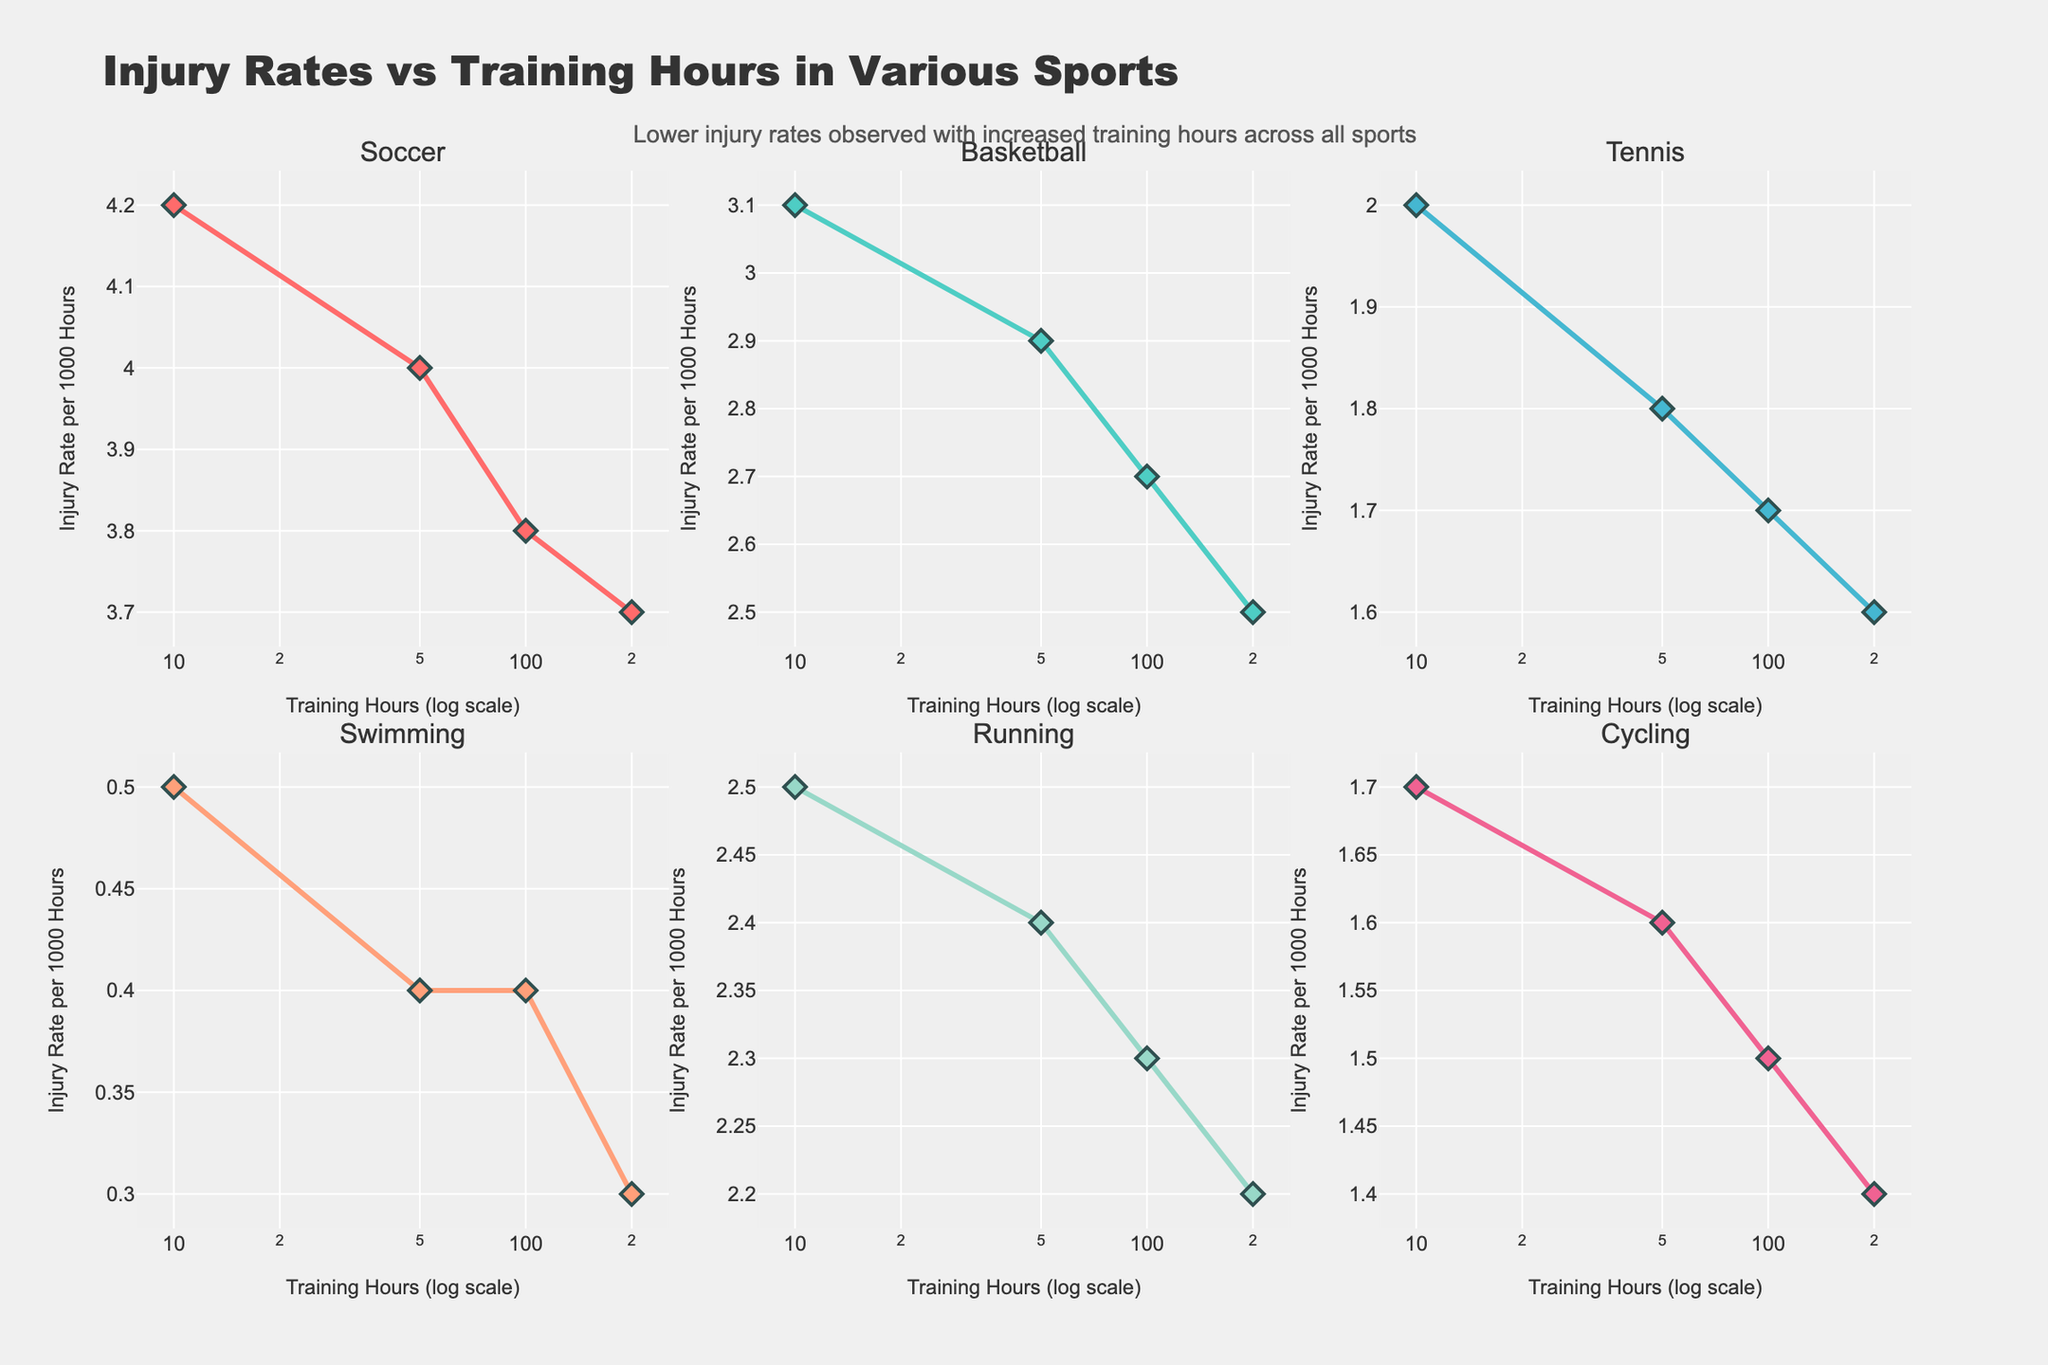How many sports are shown in the figure? Count the unique subplot titles representing different sports. There are six subplots, each labeled with a different sport.
Answer: Six What is the general trend of injury rates with increased training hours in the figure? Look at the direction of the curves in each subplot. All curves demonstrate a declining trend, which suggests lower injury rates as training hours increase.
Answer: Decreasing trend Which sport has the lowest injury rate at 10 training hours? Identify the subplot for each sport and check the injury rate corresponding to 10 training hours. Swimming has the lowest rate at 10 hours with a rate of 0.5 injuries per 1000 hours.
Answer: Swimming Which two sports exhibit the closest injury rates at 100 training hours? Find the injury rates for each sport at 100 training hours, then compare them. Running and Tennis both have an injury rate of 1.7 and 2.3 per 1000 hours respectively.
Answer: Running and Tennis Between Soccer and Basketball, which sport shows a smaller decrease in injury rate per 1000 hours as training hours increase from 10 to 200? Calculate the difference in injury rates from 10 to 200 hours for both sports. For Soccer, it's 4.2 - 3.7 = 0.5. For Basketball, it's 3.1 - 2.5 = 0.6. Soccer shows a smaller decrease.
Answer: Soccer Which sport has the steepest decline in injury rates? Determine the sport with the largest difference in injury rates from the start to the end of the training hours on the y-axis. Swimming goes from 0.5 to 0.3, which is the steepest relative decline.
Answer: Swimming What are the training hours mentioned on the x-axis in the log scale? Identify the tick marks on the x-axis. The hours of training are given as 10, 50, 100, and 200.
Answer: 10, 50, 100, 200 Which sport shows the highest injury rate at all training hours? Compare the line charts of all sports. Soccer shows the highest injury rate compared to the other sports.
Answer: Soccer What is the relationship between injury rates and training hours in Running and Cycling? Observe the trends in the subplots for Running and Cycling. Both show a decreasing trend, but Cycling has slightly lower rates throughout.
Answer: Both decrease; Cycling lower Does the figure suggest that increased training hours lead to higher or lower injury rates in sports, and is this trend uniform across all sports? Analyze the trend in each subplot for injury rates as training hours increase. All sports show decreased injury rates with higher training hours, suggesting a uniform trend.
Answer: Lower injury rates; Yes 